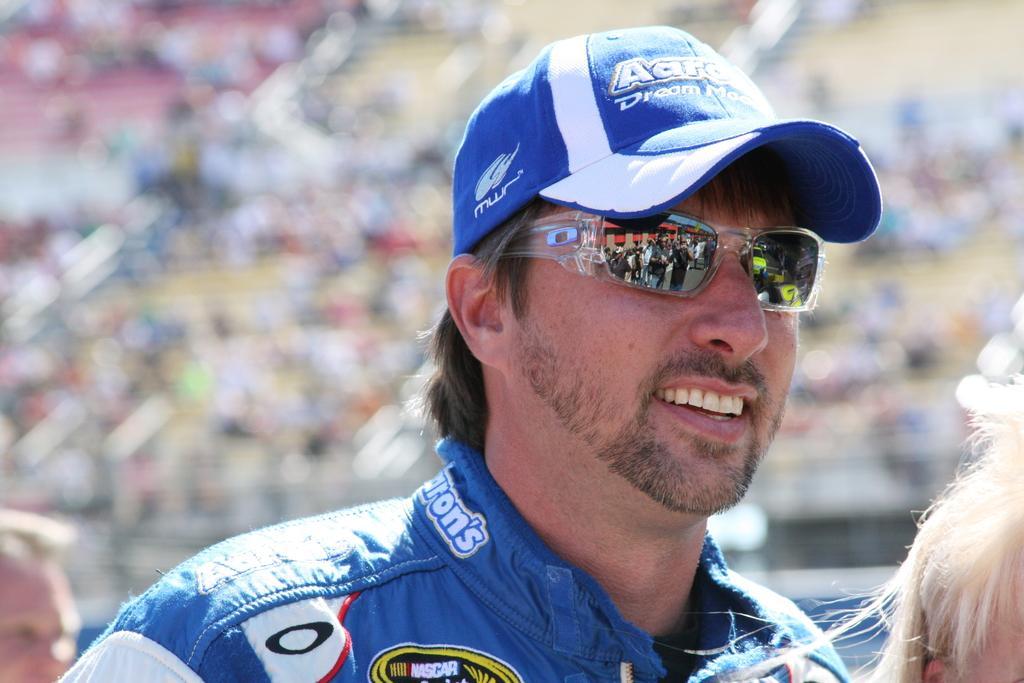Describe this image in one or two sentences. In this picture we can see a man here, he wore goggles and a cap, we can see reflection of some people in the glass, we can see a blurry background here. 